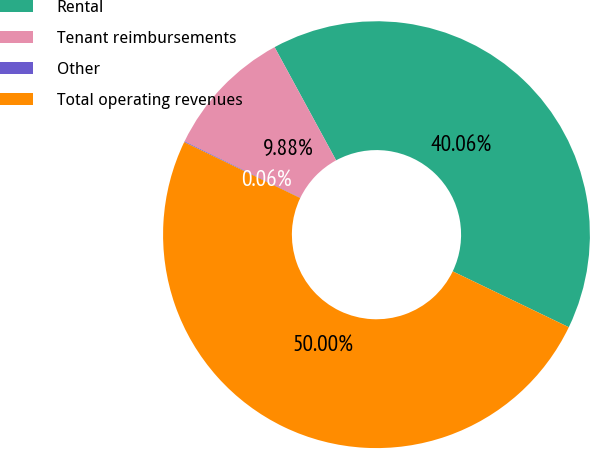<chart> <loc_0><loc_0><loc_500><loc_500><pie_chart><fcel>Rental<fcel>Tenant reimbursements<fcel>Other<fcel>Total operating revenues<nl><fcel>40.06%<fcel>9.88%<fcel>0.06%<fcel>50.0%<nl></chart> 